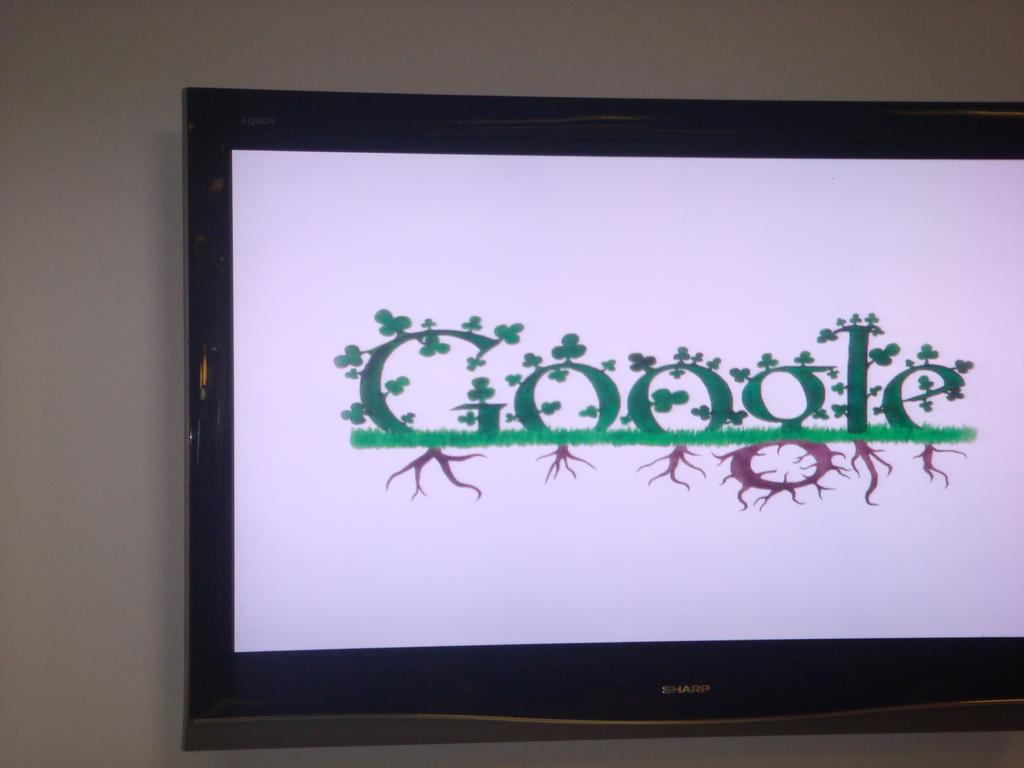<image>
Write a terse but informative summary of the picture. A sharp branded television with a google doodle on the center of the screen. 